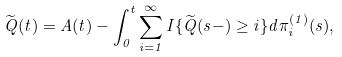<formula> <loc_0><loc_0><loc_500><loc_500>\widetilde { Q } ( t ) = A ( t ) - \int _ { 0 } ^ { t } \sum _ { i = 1 } ^ { \infty } { I } \{ \widetilde { Q } ( s - ) \geq i \} d \pi _ { i } ^ { ( 1 ) } ( s ) ,</formula> 